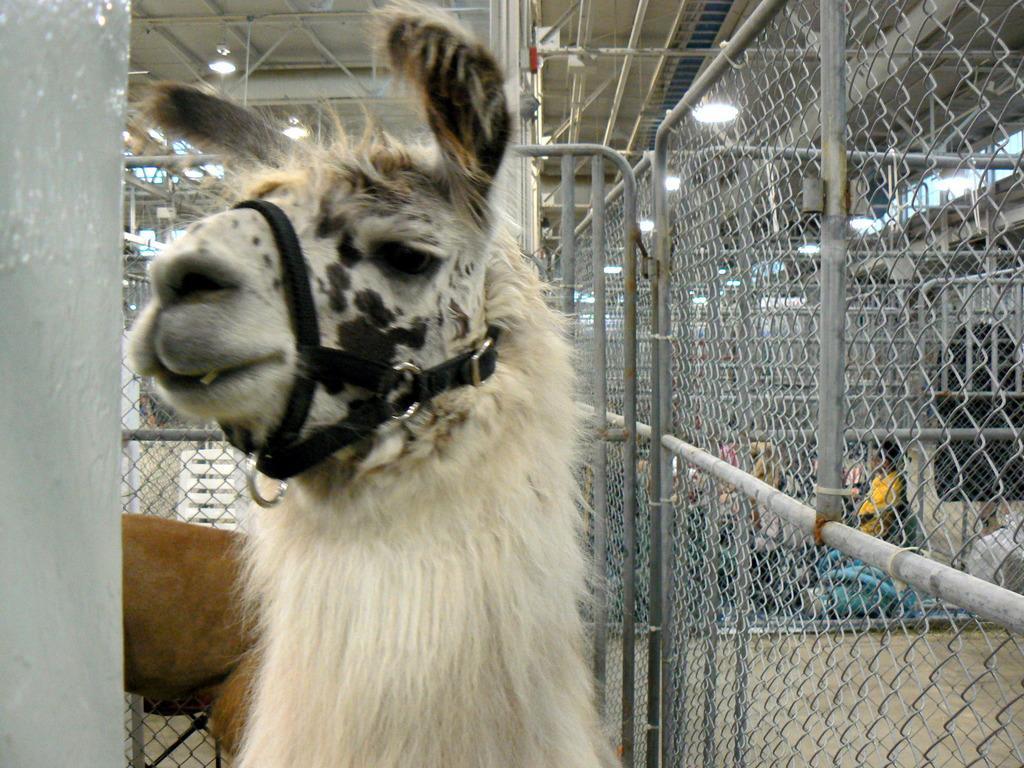Could you give a brief overview of what you see in this image? In the center of the image we can see two animals. And we can see a belt attached to the face of a front animal. On the left side of the image we can see an object. In the background, we can see fences, lights, few people and a few other objects. 